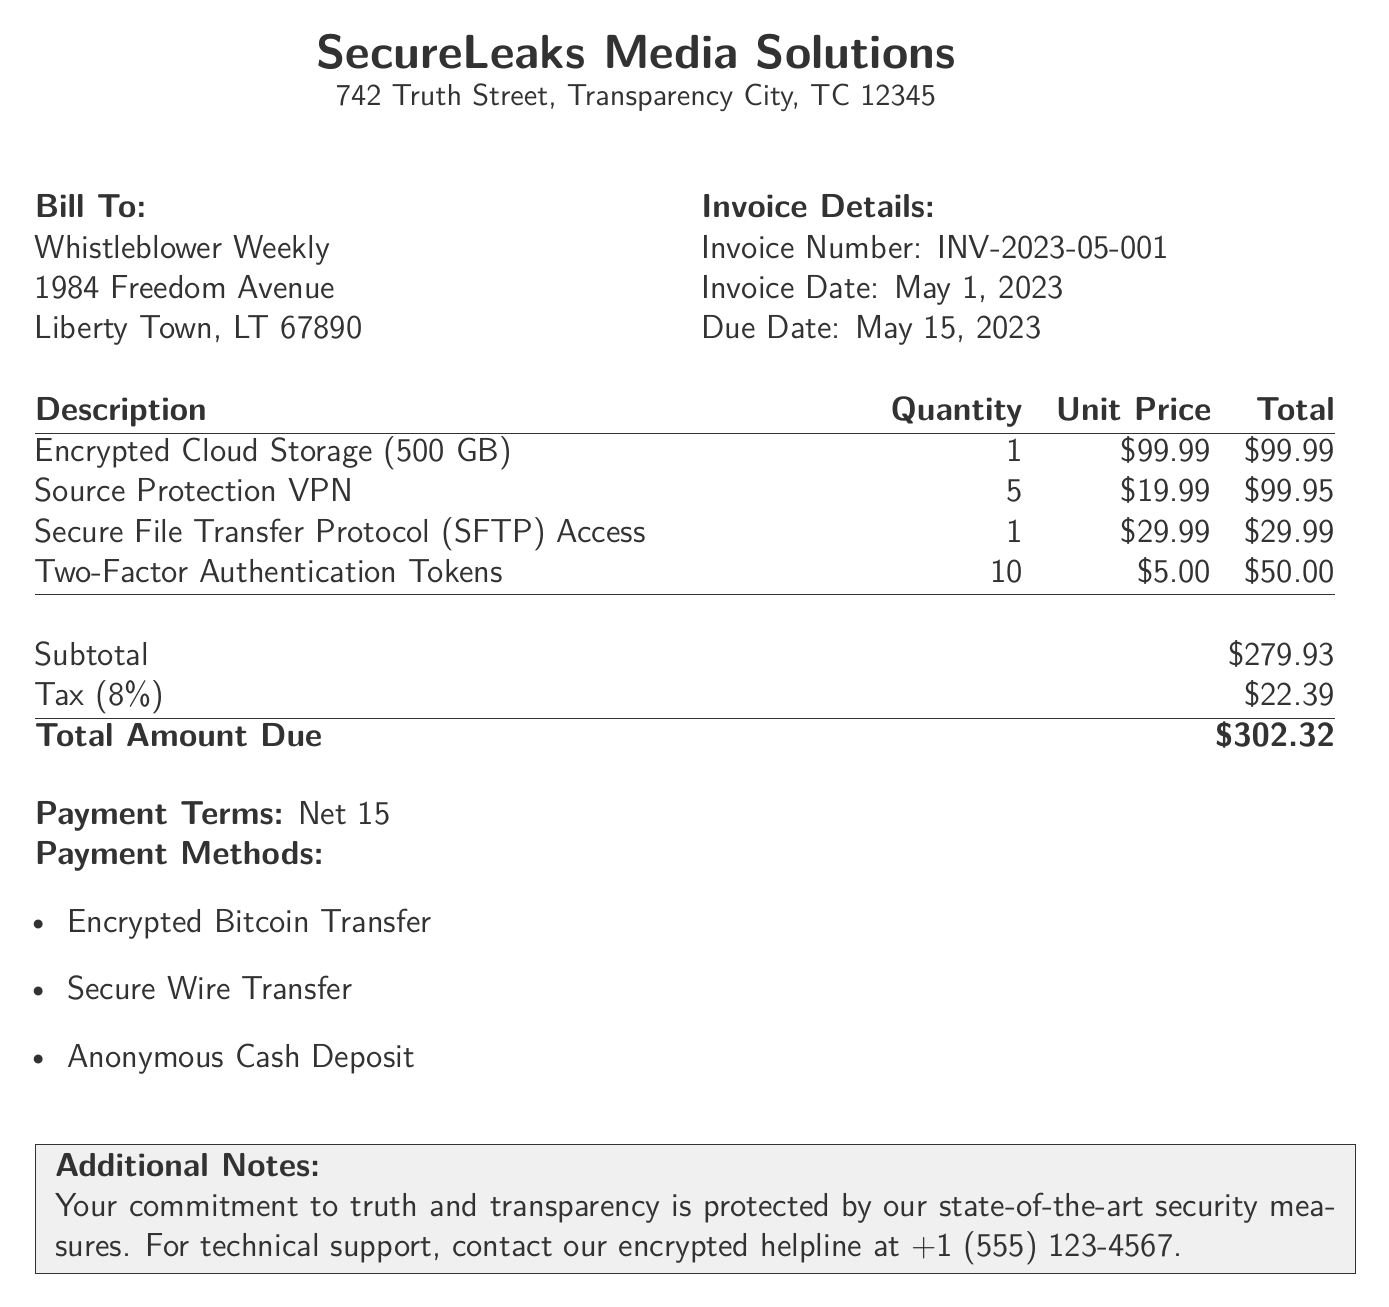What is the invoice number? The invoice number can be found in the Invoice Details section of the document.
Answer: INV-2023-05-001 What is the total amount due? The total amount due is the final figure listed at the bottom of the invoice.
Answer: $302.32 What is the due date for this invoice? The due date is specified in the Invoice Details section.
Answer: May 15, 2023 How many Two-Factor Authentication Tokens were billed? The quantity of Two-Factor Authentication Tokens is listed in the itemized services table.
Answer: 10 What is the tax rate applied to the subtotal? The tax rate can be inferred from the tax amount shown in the calculation section of the document.
Answer: 8% What type of payment methods are accepted? Payment methods are listed in the Payment Methods section of the bill.
Answer: Encrypted Bitcoin Transfer What is the subtotal before tax? The subtotal is provided just above the tax amount in the document.
Answer: $279.93 What is included in the description of the first item? The description of the first item is found in the itemized services section of the document.
Answer: Encrypted Cloud Storage (500 GB) What contact number is provided for technical support? The technical support contact number is mentioned in the Additional Notes section of the bill.
Answer: +1 (555) 123-4567 